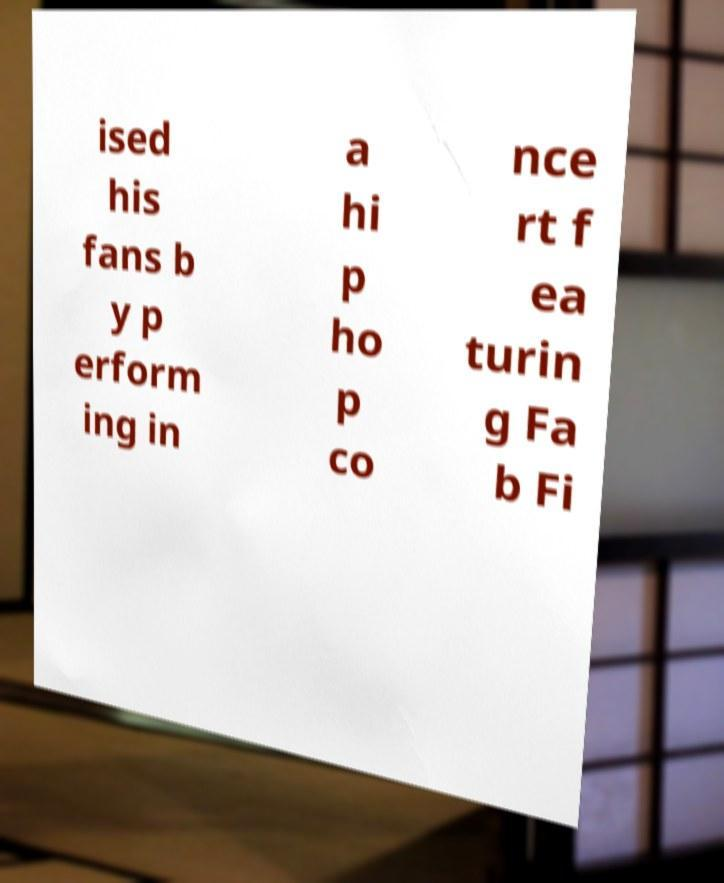Could you assist in decoding the text presented in this image and type it out clearly? ised his fans b y p erform ing in a hi p ho p co nce rt f ea turin g Fa b Fi 